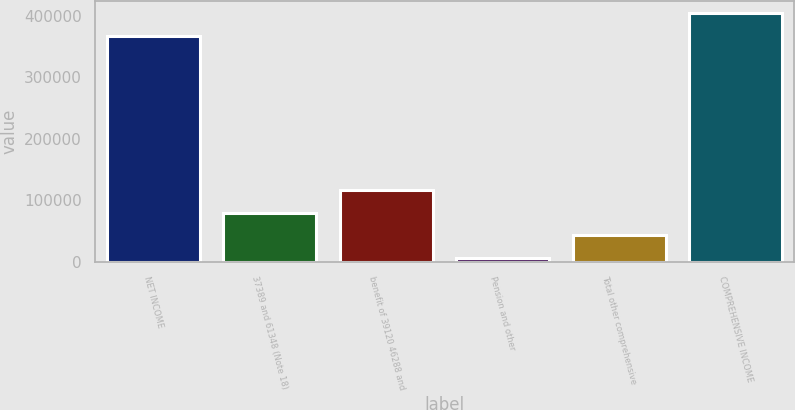Convert chart to OTSL. <chart><loc_0><loc_0><loc_500><loc_500><bar_chart><fcel>NET INCOME<fcel>37389 and 61348 (Note 18)<fcel>benefit of 39120 46288 and<fcel>Pension and other<fcel>Total other comprehensive<fcel>COMPREHENSIVE INCOME<nl><fcel>366940<fcel>79729.8<fcel>116582<fcel>6026<fcel>42877.9<fcel>403792<nl></chart> 